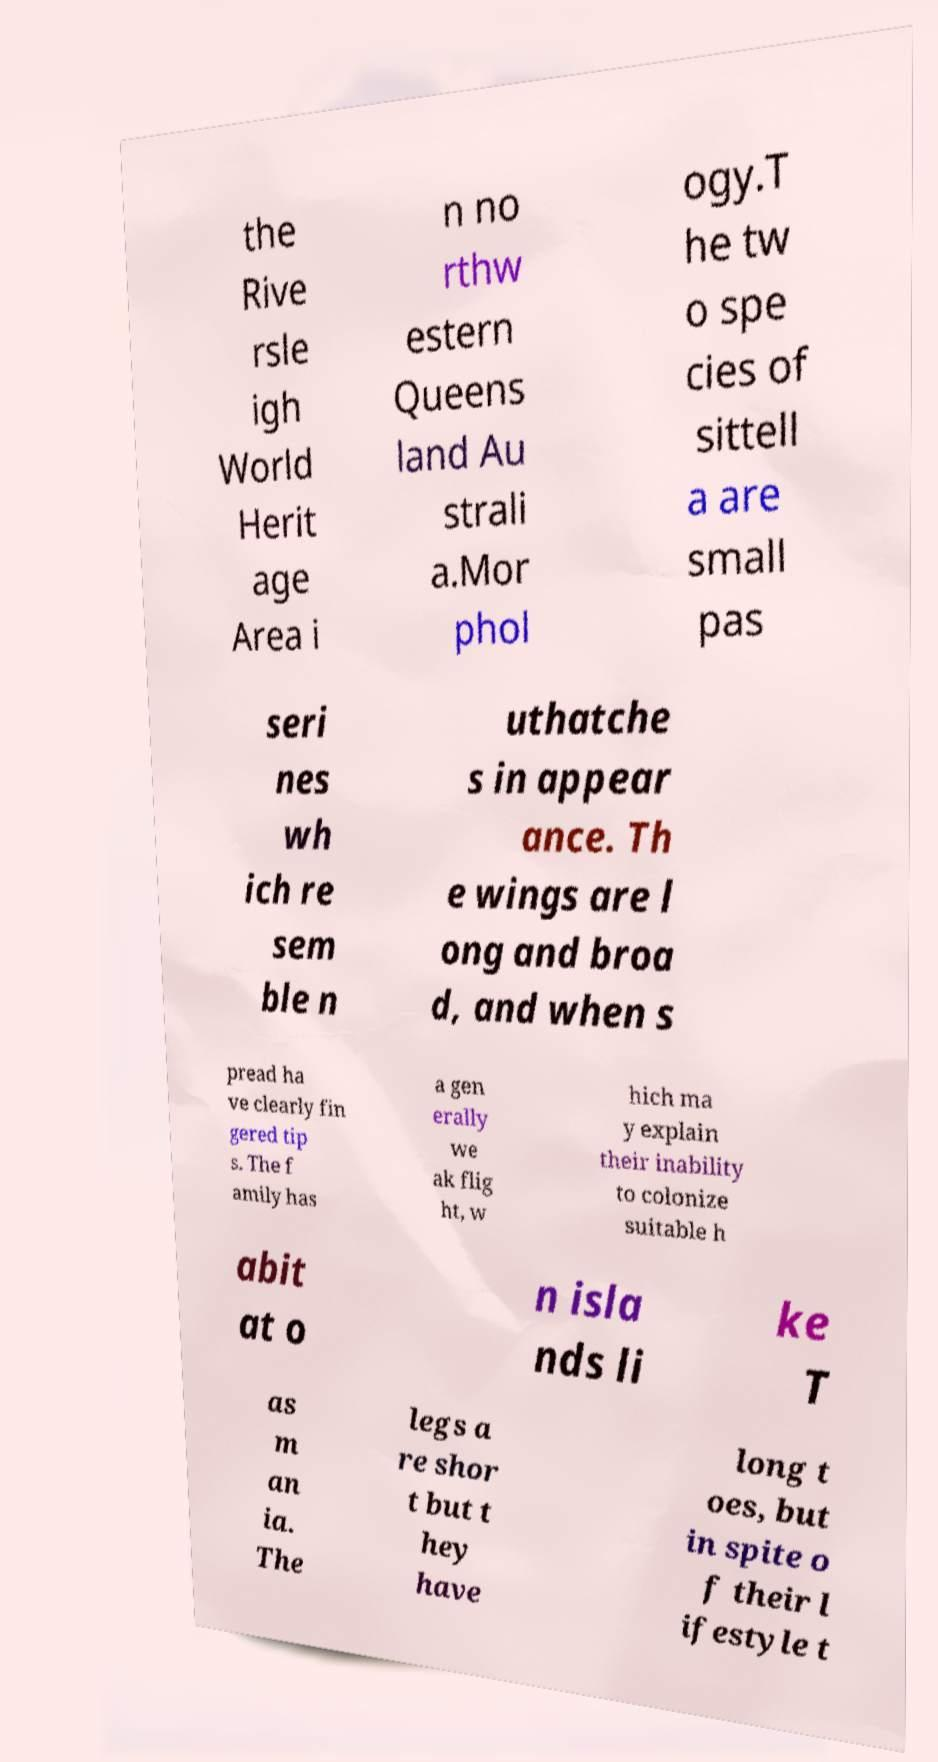Please read and relay the text visible in this image. What does it say? the Rive rsle igh World Herit age Area i n no rthw estern Queens land Au strali a.Mor phol ogy.T he tw o spe cies of sittell a are small pas seri nes wh ich re sem ble n uthatche s in appear ance. Th e wings are l ong and broa d, and when s pread ha ve clearly fin gered tip s. The f amily has a gen erally we ak flig ht, w hich ma y explain their inability to colonize suitable h abit at o n isla nds li ke T as m an ia. The legs a re shor t but t hey have long t oes, but in spite o f their l ifestyle t 